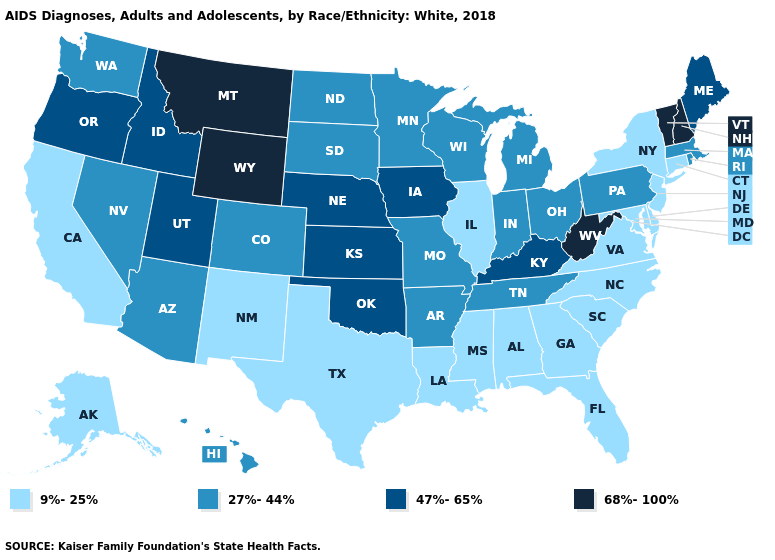What is the highest value in states that border Pennsylvania?
Write a very short answer. 68%-100%. What is the highest value in states that border Louisiana?
Short answer required. 27%-44%. What is the value of Tennessee?
Concise answer only. 27%-44%. Name the states that have a value in the range 9%-25%?
Short answer required. Alabama, Alaska, California, Connecticut, Delaware, Florida, Georgia, Illinois, Louisiana, Maryland, Mississippi, New Jersey, New Mexico, New York, North Carolina, South Carolina, Texas, Virginia. Among the states that border Indiana , does Ohio have the highest value?
Keep it brief. No. Name the states that have a value in the range 27%-44%?
Concise answer only. Arizona, Arkansas, Colorado, Hawaii, Indiana, Massachusetts, Michigan, Minnesota, Missouri, Nevada, North Dakota, Ohio, Pennsylvania, Rhode Island, South Dakota, Tennessee, Washington, Wisconsin. Name the states that have a value in the range 9%-25%?
Write a very short answer. Alabama, Alaska, California, Connecticut, Delaware, Florida, Georgia, Illinois, Louisiana, Maryland, Mississippi, New Jersey, New Mexico, New York, North Carolina, South Carolina, Texas, Virginia. Does the map have missing data?
Give a very brief answer. No. Name the states that have a value in the range 68%-100%?
Keep it brief. Montana, New Hampshire, Vermont, West Virginia, Wyoming. Does Vermont have the highest value in the USA?
Short answer required. Yes. Name the states that have a value in the range 27%-44%?
Give a very brief answer. Arizona, Arkansas, Colorado, Hawaii, Indiana, Massachusetts, Michigan, Minnesota, Missouri, Nevada, North Dakota, Ohio, Pennsylvania, Rhode Island, South Dakota, Tennessee, Washington, Wisconsin. Among the states that border California , which have the lowest value?
Quick response, please. Arizona, Nevada. Is the legend a continuous bar?
Give a very brief answer. No. What is the lowest value in states that border Idaho?
Be succinct. 27%-44%. Does Tennessee have a lower value than Indiana?
Give a very brief answer. No. 